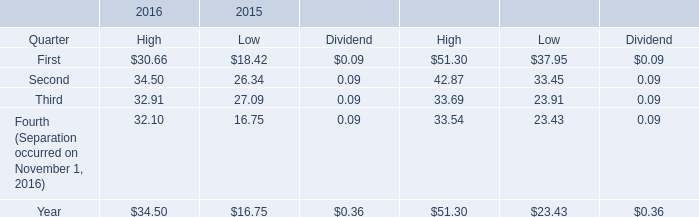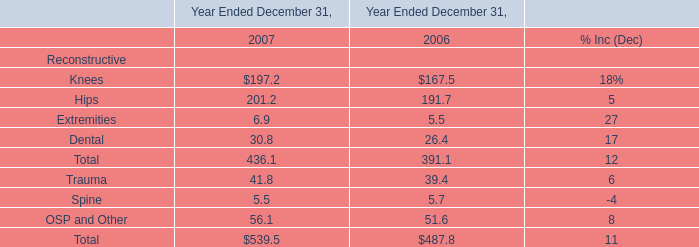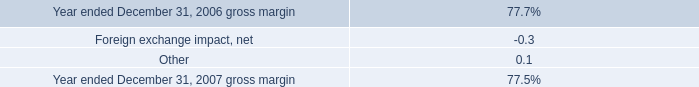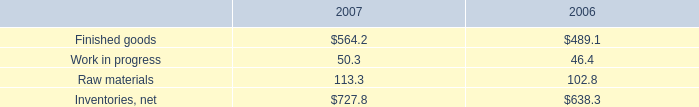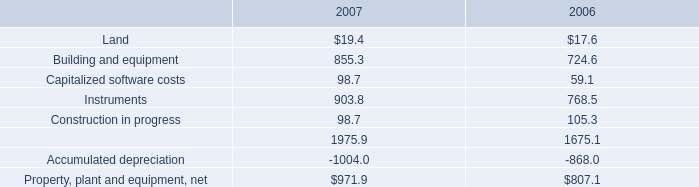As As the chart 3 shows,which year is the value of the Raw materials higher? 
Answer: 2007. 